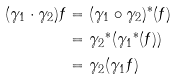<formula> <loc_0><loc_0><loc_500><loc_500>( \gamma _ { 1 } \cdot \gamma _ { 2 } ) f & = ( \gamma _ { 1 } \circ \gamma _ { 2 } ) ^ { \ast } ( f ) \\ & = { \gamma _ { 2 } } ^ { \ast } ( { \gamma _ { 1 } } ^ { \ast } ( f ) ) \\ & = \gamma _ { 2 } ( \gamma _ { 1 } f )</formula> 